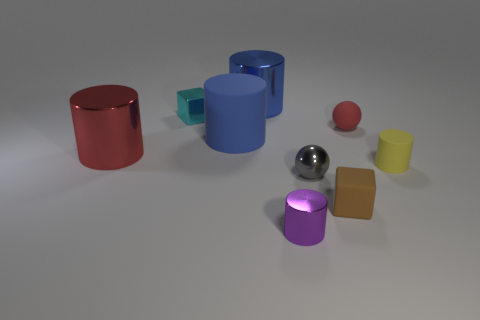Are there any reflective objects, and if so, what shapes are they? Yes, there is one highly reflective object which is spherical and silver in color, showing a clear reflection of the environment on its surface. 